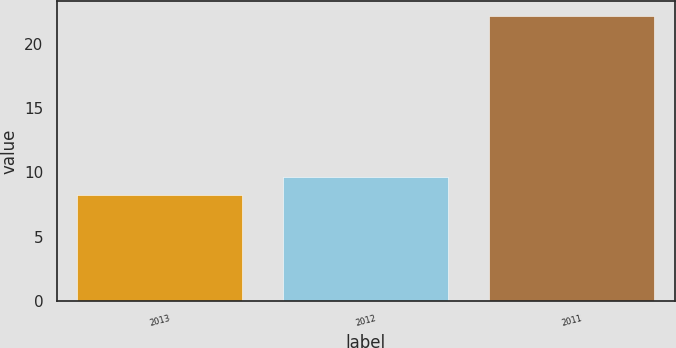Convert chart. <chart><loc_0><loc_0><loc_500><loc_500><bar_chart><fcel>2013<fcel>2012<fcel>2011<nl><fcel>8.2<fcel>9.6<fcel>22.2<nl></chart> 